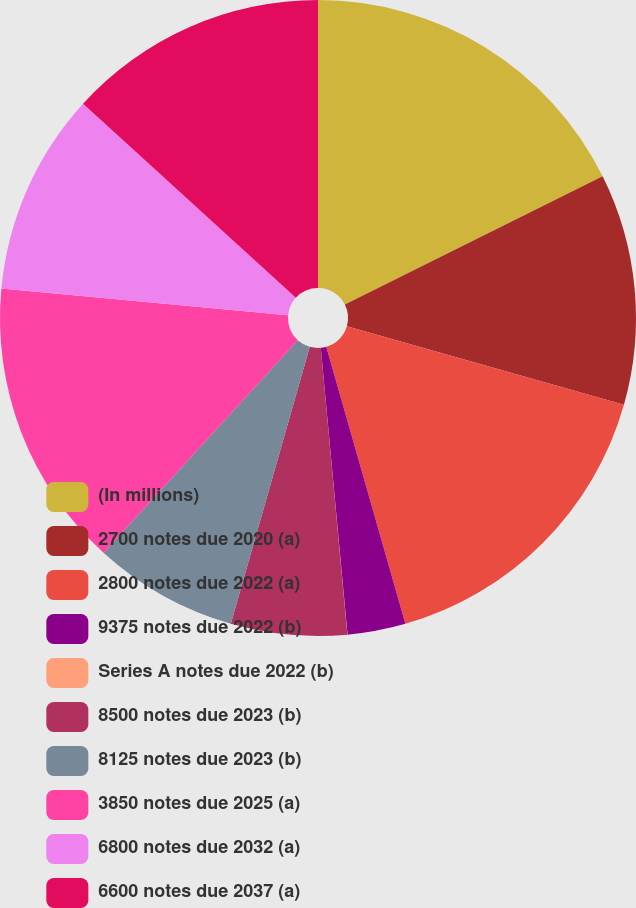<chart> <loc_0><loc_0><loc_500><loc_500><pie_chart><fcel>(In millions)<fcel>2700 notes due 2020 (a)<fcel>2800 notes due 2022 (a)<fcel>9375 notes due 2022 (b)<fcel>Series A notes due 2022 (b)<fcel>8500 notes due 2023 (b)<fcel>8125 notes due 2023 (b)<fcel>3850 notes due 2025 (a)<fcel>6800 notes due 2032 (a)<fcel>6600 notes due 2037 (a)<nl><fcel>17.64%<fcel>11.76%<fcel>16.17%<fcel>2.95%<fcel>0.01%<fcel>5.89%<fcel>7.36%<fcel>14.7%<fcel>10.29%<fcel>13.23%<nl></chart> 